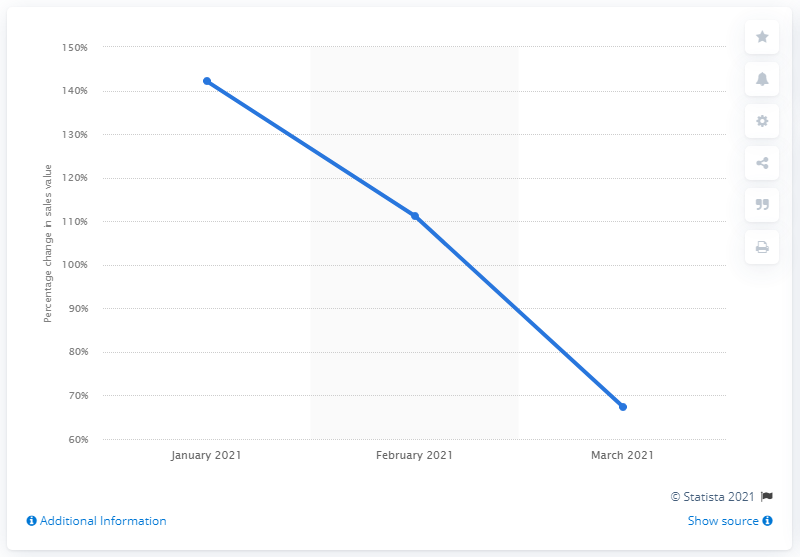Draw attention to some important aspects in this diagram. In January 2021, the online sales of consumer packaged goods in Italy showed a growth of 142.1% compared to the same month in 2020, indicating a significant increase in the demand for these products. The percentage growth was compared to January 2020 in January 2021. Online sales of consumer packaged goods in Italy grew by 67.4% in March 2021 compared to the same period in 2020. 